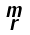Convert formula to latex. <formula><loc_0><loc_0><loc_500><loc_500>\begin{smallmatrix} m \\ r \end{smallmatrix}</formula> 